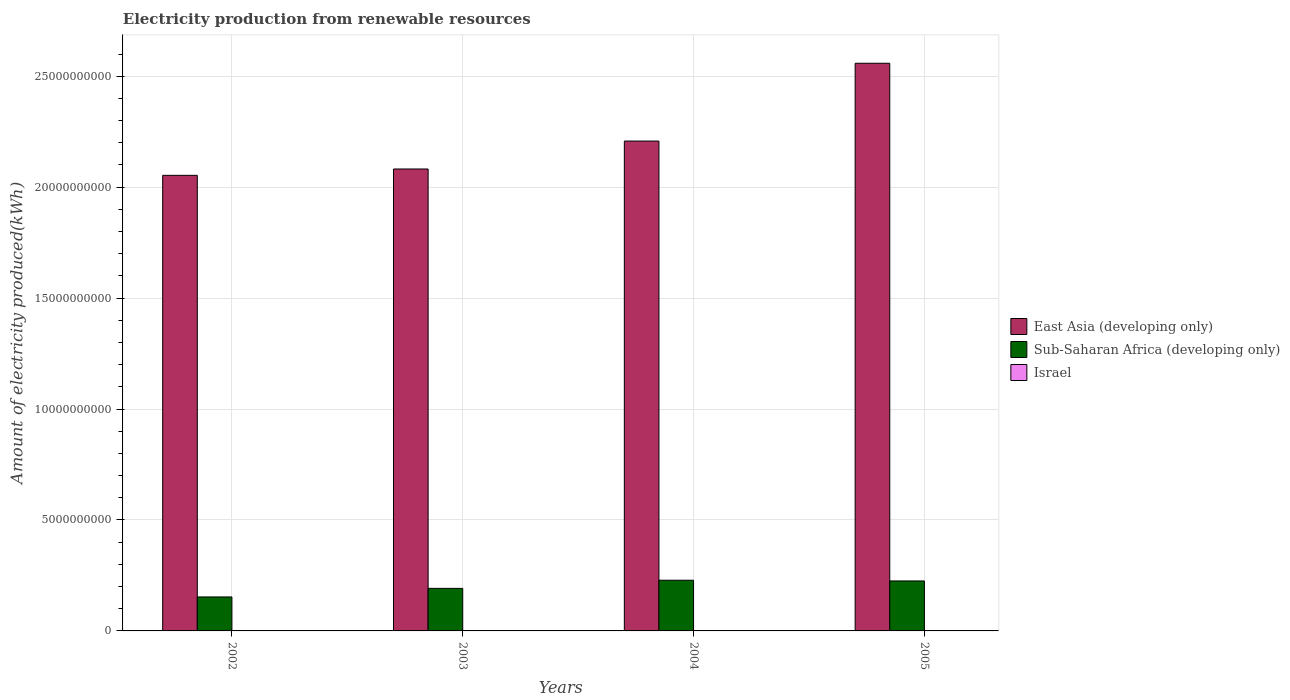Are the number of bars per tick equal to the number of legend labels?
Your response must be concise. Yes. Are the number of bars on each tick of the X-axis equal?
Ensure brevity in your answer.  Yes. How many bars are there on the 4th tick from the right?
Make the answer very short. 3. What is the label of the 2nd group of bars from the left?
Offer a terse response. 2003. What is the amount of electricity produced in East Asia (developing only) in 2004?
Offer a very short reply. 2.21e+1. Across all years, what is the maximum amount of electricity produced in East Asia (developing only)?
Your response must be concise. 2.56e+1. Across all years, what is the minimum amount of electricity produced in Sub-Saharan Africa (developing only)?
Give a very brief answer. 1.53e+09. In which year was the amount of electricity produced in Sub-Saharan Africa (developing only) maximum?
Keep it short and to the point. 2004. What is the total amount of electricity produced in East Asia (developing only) in the graph?
Ensure brevity in your answer.  8.90e+1. What is the difference between the amount of electricity produced in Sub-Saharan Africa (developing only) in 2002 and that in 2003?
Your response must be concise. -3.87e+08. What is the difference between the amount of electricity produced in East Asia (developing only) in 2005 and the amount of electricity produced in Israel in 2002?
Keep it short and to the point. 2.56e+1. What is the average amount of electricity produced in Israel per year?
Offer a very short reply. 1.12e+07. In the year 2003, what is the difference between the amount of electricity produced in East Asia (developing only) and amount of electricity produced in Sub-Saharan Africa (developing only)?
Make the answer very short. 1.89e+1. What is the ratio of the amount of electricity produced in Israel in 2004 to that in 2005?
Offer a very short reply. 1. Is the amount of electricity produced in East Asia (developing only) in 2004 less than that in 2005?
Offer a terse response. Yes. What is the difference between the highest and the second highest amount of electricity produced in East Asia (developing only)?
Provide a succinct answer. 3.51e+09. What is the difference between the highest and the lowest amount of electricity produced in East Asia (developing only)?
Your response must be concise. 5.05e+09. In how many years, is the amount of electricity produced in Israel greater than the average amount of electricity produced in Israel taken over all years?
Provide a short and direct response. 1. What does the 2nd bar from the left in 2002 represents?
Keep it short and to the point. Sub-Saharan Africa (developing only). What does the 2nd bar from the right in 2003 represents?
Provide a succinct answer. Sub-Saharan Africa (developing only). Is it the case that in every year, the sum of the amount of electricity produced in Israel and amount of electricity produced in East Asia (developing only) is greater than the amount of electricity produced in Sub-Saharan Africa (developing only)?
Offer a very short reply. Yes. How many bars are there?
Your answer should be compact. 12. Are all the bars in the graph horizontal?
Offer a very short reply. No. Are the values on the major ticks of Y-axis written in scientific E-notation?
Keep it short and to the point. No. Does the graph contain any zero values?
Ensure brevity in your answer.  No. Where does the legend appear in the graph?
Keep it short and to the point. Center right. How many legend labels are there?
Keep it short and to the point. 3. What is the title of the graph?
Make the answer very short. Electricity production from renewable resources. What is the label or title of the Y-axis?
Your response must be concise. Amount of electricity produced(kWh). What is the Amount of electricity produced(kWh) of East Asia (developing only) in 2002?
Your answer should be very brief. 2.05e+1. What is the Amount of electricity produced(kWh) of Sub-Saharan Africa (developing only) in 2002?
Your response must be concise. 1.53e+09. What is the Amount of electricity produced(kWh) in Israel in 2002?
Ensure brevity in your answer.  1.10e+07. What is the Amount of electricity produced(kWh) of East Asia (developing only) in 2003?
Keep it short and to the point. 2.08e+1. What is the Amount of electricity produced(kWh) of Sub-Saharan Africa (developing only) in 2003?
Provide a succinct answer. 1.92e+09. What is the Amount of electricity produced(kWh) of Israel in 2003?
Your answer should be very brief. 1.20e+07. What is the Amount of electricity produced(kWh) of East Asia (developing only) in 2004?
Your answer should be very brief. 2.21e+1. What is the Amount of electricity produced(kWh) in Sub-Saharan Africa (developing only) in 2004?
Provide a succinct answer. 2.28e+09. What is the Amount of electricity produced(kWh) of Israel in 2004?
Offer a very short reply. 1.10e+07. What is the Amount of electricity produced(kWh) in East Asia (developing only) in 2005?
Make the answer very short. 2.56e+1. What is the Amount of electricity produced(kWh) in Sub-Saharan Africa (developing only) in 2005?
Your answer should be very brief. 2.25e+09. What is the Amount of electricity produced(kWh) of Israel in 2005?
Your response must be concise. 1.10e+07. Across all years, what is the maximum Amount of electricity produced(kWh) in East Asia (developing only)?
Offer a terse response. 2.56e+1. Across all years, what is the maximum Amount of electricity produced(kWh) in Sub-Saharan Africa (developing only)?
Your answer should be very brief. 2.28e+09. Across all years, what is the maximum Amount of electricity produced(kWh) in Israel?
Your answer should be very brief. 1.20e+07. Across all years, what is the minimum Amount of electricity produced(kWh) in East Asia (developing only)?
Make the answer very short. 2.05e+1. Across all years, what is the minimum Amount of electricity produced(kWh) of Sub-Saharan Africa (developing only)?
Ensure brevity in your answer.  1.53e+09. Across all years, what is the minimum Amount of electricity produced(kWh) of Israel?
Provide a succinct answer. 1.10e+07. What is the total Amount of electricity produced(kWh) of East Asia (developing only) in the graph?
Keep it short and to the point. 8.90e+1. What is the total Amount of electricity produced(kWh) of Sub-Saharan Africa (developing only) in the graph?
Your answer should be very brief. 7.99e+09. What is the total Amount of electricity produced(kWh) of Israel in the graph?
Ensure brevity in your answer.  4.50e+07. What is the difference between the Amount of electricity produced(kWh) in East Asia (developing only) in 2002 and that in 2003?
Provide a short and direct response. -2.86e+08. What is the difference between the Amount of electricity produced(kWh) in Sub-Saharan Africa (developing only) in 2002 and that in 2003?
Offer a terse response. -3.87e+08. What is the difference between the Amount of electricity produced(kWh) in East Asia (developing only) in 2002 and that in 2004?
Your answer should be very brief. -1.54e+09. What is the difference between the Amount of electricity produced(kWh) in Sub-Saharan Africa (developing only) in 2002 and that in 2004?
Make the answer very short. -7.54e+08. What is the difference between the Amount of electricity produced(kWh) of Israel in 2002 and that in 2004?
Give a very brief answer. 0. What is the difference between the Amount of electricity produced(kWh) of East Asia (developing only) in 2002 and that in 2005?
Make the answer very short. -5.05e+09. What is the difference between the Amount of electricity produced(kWh) of Sub-Saharan Africa (developing only) in 2002 and that in 2005?
Keep it short and to the point. -7.21e+08. What is the difference between the Amount of electricity produced(kWh) of Israel in 2002 and that in 2005?
Provide a succinct answer. 0. What is the difference between the Amount of electricity produced(kWh) in East Asia (developing only) in 2003 and that in 2004?
Keep it short and to the point. -1.26e+09. What is the difference between the Amount of electricity produced(kWh) of Sub-Saharan Africa (developing only) in 2003 and that in 2004?
Keep it short and to the point. -3.67e+08. What is the difference between the Amount of electricity produced(kWh) in Israel in 2003 and that in 2004?
Your answer should be compact. 1.00e+06. What is the difference between the Amount of electricity produced(kWh) of East Asia (developing only) in 2003 and that in 2005?
Provide a short and direct response. -4.76e+09. What is the difference between the Amount of electricity produced(kWh) in Sub-Saharan Africa (developing only) in 2003 and that in 2005?
Your answer should be very brief. -3.34e+08. What is the difference between the Amount of electricity produced(kWh) of Israel in 2003 and that in 2005?
Your answer should be very brief. 1.00e+06. What is the difference between the Amount of electricity produced(kWh) in East Asia (developing only) in 2004 and that in 2005?
Give a very brief answer. -3.51e+09. What is the difference between the Amount of electricity produced(kWh) of Sub-Saharan Africa (developing only) in 2004 and that in 2005?
Ensure brevity in your answer.  3.30e+07. What is the difference between the Amount of electricity produced(kWh) in Israel in 2004 and that in 2005?
Offer a very short reply. 0. What is the difference between the Amount of electricity produced(kWh) in East Asia (developing only) in 2002 and the Amount of electricity produced(kWh) in Sub-Saharan Africa (developing only) in 2003?
Provide a short and direct response. 1.86e+1. What is the difference between the Amount of electricity produced(kWh) in East Asia (developing only) in 2002 and the Amount of electricity produced(kWh) in Israel in 2003?
Give a very brief answer. 2.05e+1. What is the difference between the Amount of electricity produced(kWh) in Sub-Saharan Africa (developing only) in 2002 and the Amount of electricity produced(kWh) in Israel in 2003?
Provide a succinct answer. 1.52e+09. What is the difference between the Amount of electricity produced(kWh) of East Asia (developing only) in 2002 and the Amount of electricity produced(kWh) of Sub-Saharan Africa (developing only) in 2004?
Offer a terse response. 1.82e+1. What is the difference between the Amount of electricity produced(kWh) in East Asia (developing only) in 2002 and the Amount of electricity produced(kWh) in Israel in 2004?
Give a very brief answer. 2.05e+1. What is the difference between the Amount of electricity produced(kWh) of Sub-Saharan Africa (developing only) in 2002 and the Amount of electricity produced(kWh) of Israel in 2004?
Provide a short and direct response. 1.52e+09. What is the difference between the Amount of electricity produced(kWh) in East Asia (developing only) in 2002 and the Amount of electricity produced(kWh) in Sub-Saharan Africa (developing only) in 2005?
Make the answer very short. 1.83e+1. What is the difference between the Amount of electricity produced(kWh) of East Asia (developing only) in 2002 and the Amount of electricity produced(kWh) of Israel in 2005?
Offer a very short reply. 2.05e+1. What is the difference between the Amount of electricity produced(kWh) of Sub-Saharan Africa (developing only) in 2002 and the Amount of electricity produced(kWh) of Israel in 2005?
Your answer should be very brief. 1.52e+09. What is the difference between the Amount of electricity produced(kWh) of East Asia (developing only) in 2003 and the Amount of electricity produced(kWh) of Sub-Saharan Africa (developing only) in 2004?
Give a very brief answer. 1.85e+1. What is the difference between the Amount of electricity produced(kWh) of East Asia (developing only) in 2003 and the Amount of electricity produced(kWh) of Israel in 2004?
Provide a short and direct response. 2.08e+1. What is the difference between the Amount of electricity produced(kWh) of Sub-Saharan Africa (developing only) in 2003 and the Amount of electricity produced(kWh) of Israel in 2004?
Your response must be concise. 1.91e+09. What is the difference between the Amount of electricity produced(kWh) in East Asia (developing only) in 2003 and the Amount of electricity produced(kWh) in Sub-Saharan Africa (developing only) in 2005?
Give a very brief answer. 1.86e+1. What is the difference between the Amount of electricity produced(kWh) of East Asia (developing only) in 2003 and the Amount of electricity produced(kWh) of Israel in 2005?
Give a very brief answer. 2.08e+1. What is the difference between the Amount of electricity produced(kWh) in Sub-Saharan Africa (developing only) in 2003 and the Amount of electricity produced(kWh) in Israel in 2005?
Your answer should be compact. 1.91e+09. What is the difference between the Amount of electricity produced(kWh) of East Asia (developing only) in 2004 and the Amount of electricity produced(kWh) of Sub-Saharan Africa (developing only) in 2005?
Your answer should be compact. 1.98e+1. What is the difference between the Amount of electricity produced(kWh) in East Asia (developing only) in 2004 and the Amount of electricity produced(kWh) in Israel in 2005?
Provide a short and direct response. 2.21e+1. What is the difference between the Amount of electricity produced(kWh) in Sub-Saharan Africa (developing only) in 2004 and the Amount of electricity produced(kWh) in Israel in 2005?
Give a very brief answer. 2.27e+09. What is the average Amount of electricity produced(kWh) in East Asia (developing only) per year?
Give a very brief answer. 2.23e+1. What is the average Amount of electricity produced(kWh) of Sub-Saharan Africa (developing only) per year?
Ensure brevity in your answer.  2.00e+09. What is the average Amount of electricity produced(kWh) of Israel per year?
Provide a short and direct response. 1.12e+07. In the year 2002, what is the difference between the Amount of electricity produced(kWh) of East Asia (developing only) and Amount of electricity produced(kWh) of Sub-Saharan Africa (developing only)?
Offer a terse response. 1.90e+1. In the year 2002, what is the difference between the Amount of electricity produced(kWh) in East Asia (developing only) and Amount of electricity produced(kWh) in Israel?
Give a very brief answer. 2.05e+1. In the year 2002, what is the difference between the Amount of electricity produced(kWh) in Sub-Saharan Africa (developing only) and Amount of electricity produced(kWh) in Israel?
Your response must be concise. 1.52e+09. In the year 2003, what is the difference between the Amount of electricity produced(kWh) in East Asia (developing only) and Amount of electricity produced(kWh) in Sub-Saharan Africa (developing only)?
Offer a very short reply. 1.89e+1. In the year 2003, what is the difference between the Amount of electricity produced(kWh) in East Asia (developing only) and Amount of electricity produced(kWh) in Israel?
Your answer should be compact. 2.08e+1. In the year 2003, what is the difference between the Amount of electricity produced(kWh) of Sub-Saharan Africa (developing only) and Amount of electricity produced(kWh) of Israel?
Provide a succinct answer. 1.91e+09. In the year 2004, what is the difference between the Amount of electricity produced(kWh) of East Asia (developing only) and Amount of electricity produced(kWh) of Sub-Saharan Africa (developing only)?
Your response must be concise. 1.98e+1. In the year 2004, what is the difference between the Amount of electricity produced(kWh) in East Asia (developing only) and Amount of electricity produced(kWh) in Israel?
Provide a succinct answer. 2.21e+1. In the year 2004, what is the difference between the Amount of electricity produced(kWh) in Sub-Saharan Africa (developing only) and Amount of electricity produced(kWh) in Israel?
Keep it short and to the point. 2.27e+09. In the year 2005, what is the difference between the Amount of electricity produced(kWh) of East Asia (developing only) and Amount of electricity produced(kWh) of Sub-Saharan Africa (developing only)?
Your answer should be compact. 2.33e+1. In the year 2005, what is the difference between the Amount of electricity produced(kWh) in East Asia (developing only) and Amount of electricity produced(kWh) in Israel?
Offer a very short reply. 2.56e+1. In the year 2005, what is the difference between the Amount of electricity produced(kWh) in Sub-Saharan Africa (developing only) and Amount of electricity produced(kWh) in Israel?
Give a very brief answer. 2.24e+09. What is the ratio of the Amount of electricity produced(kWh) in East Asia (developing only) in 2002 to that in 2003?
Your answer should be compact. 0.99. What is the ratio of the Amount of electricity produced(kWh) in Sub-Saharan Africa (developing only) in 2002 to that in 2003?
Ensure brevity in your answer.  0.8. What is the ratio of the Amount of electricity produced(kWh) of Israel in 2002 to that in 2003?
Provide a succinct answer. 0.92. What is the ratio of the Amount of electricity produced(kWh) in Sub-Saharan Africa (developing only) in 2002 to that in 2004?
Your answer should be compact. 0.67. What is the ratio of the Amount of electricity produced(kWh) of Israel in 2002 to that in 2004?
Offer a very short reply. 1. What is the ratio of the Amount of electricity produced(kWh) of East Asia (developing only) in 2002 to that in 2005?
Make the answer very short. 0.8. What is the ratio of the Amount of electricity produced(kWh) in Sub-Saharan Africa (developing only) in 2002 to that in 2005?
Ensure brevity in your answer.  0.68. What is the ratio of the Amount of electricity produced(kWh) in East Asia (developing only) in 2003 to that in 2004?
Ensure brevity in your answer.  0.94. What is the ratio of the Amount of electricity produced(kWh) of Sub-Saharan Africa (developing only) in 2003 to that in 2004?
Give a very brief answer. 0.84. What is the ratio of the Amount of electricity produced(kWh) in Israel in 2003 to that in 2004?
Give a very brief answer. 1.09. What is the ratio of the Amount of electricity produced(kWh) of East Asia (developing only) in 2003 to that in 2005?
Provide a short and direct response. 0.81. What is the ratio of the Amount of electricity produced(kWh) in Sub-Saharan Africa (developing only) in 2003 to that in 2005?
Ensure brevity in your answer.  0.85. What is the ratio of the Amount of electricity produced(kWh) in East Asia (developing only) in 2004 to that in 2005?
Provide a short and direct response. 0.86. What is the ratio of the Amount of electricity produced(kWh) in Sub-Saharan Africa (developing only) in 2004 to that in 2005?
Give a very brief answer. 1.01. What is the difference between the highest and the second highest Amount of electricity produced(kWh) of East Asia (developing only)?
Your answer should be very brief. 3.51e+09. What is the difference between the highest and the second highest Amount of electricity produced(kWh) in Sub-Saharan Africa (developing only)?
Offer a terse response. 3.30e+07. What is the difference between the highest and the lowest Amount of electricity produced(kWh) in East Asia (developing only)?
Provide a succinct answer. 5.05e+09. What is the difference between the highest and the lowest Amount of electricity produced(kWh) of Sub-Saharan Africa (developing only)?
Keep it short and to the point. 7.54e+08. 